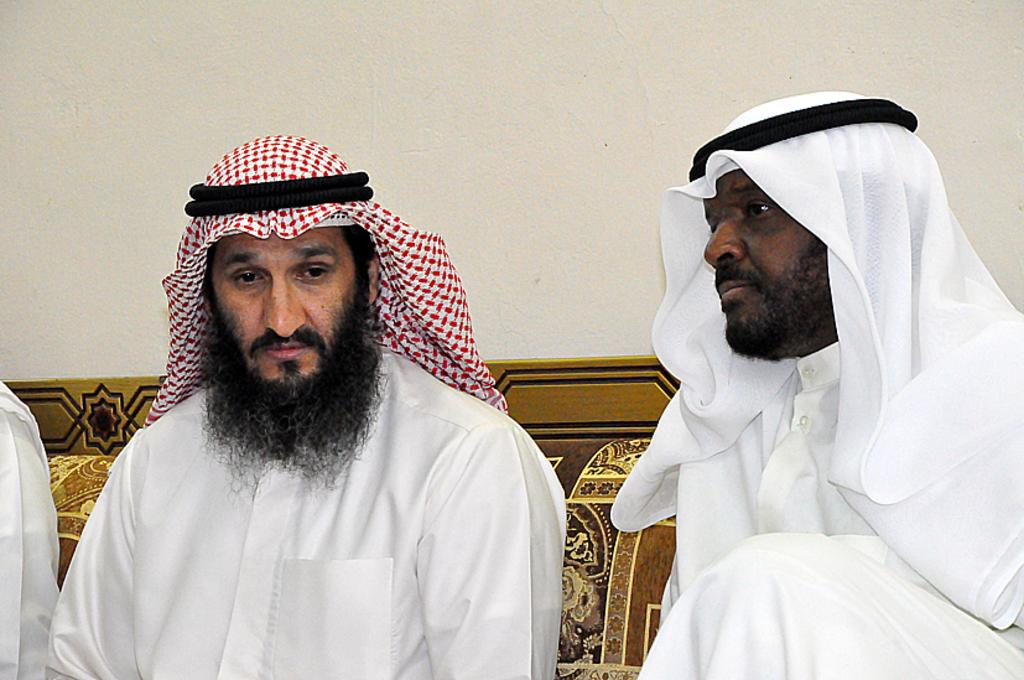How many people are in the image? There are persons in the image, but the exact number is not specified. What can be seen in the background of the image? There is a wall and other unspecified objects in the background of the image. What type of pet is visible in the image? There is no pet present in the image. How many cubs can be seen playing with the persons in the image? There are no cubs present in the image. 